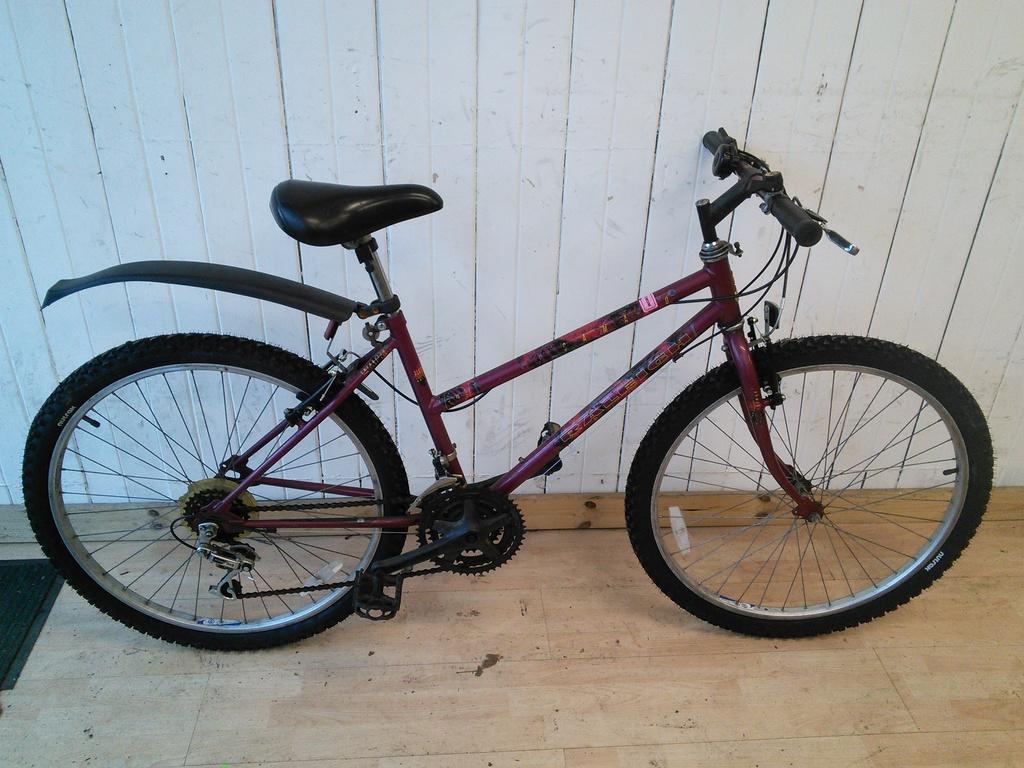In one or two sentences, can you explain what this image depicts? In this image there is a cycle parked on the wooden surface. In the background there is a wooden wall. 